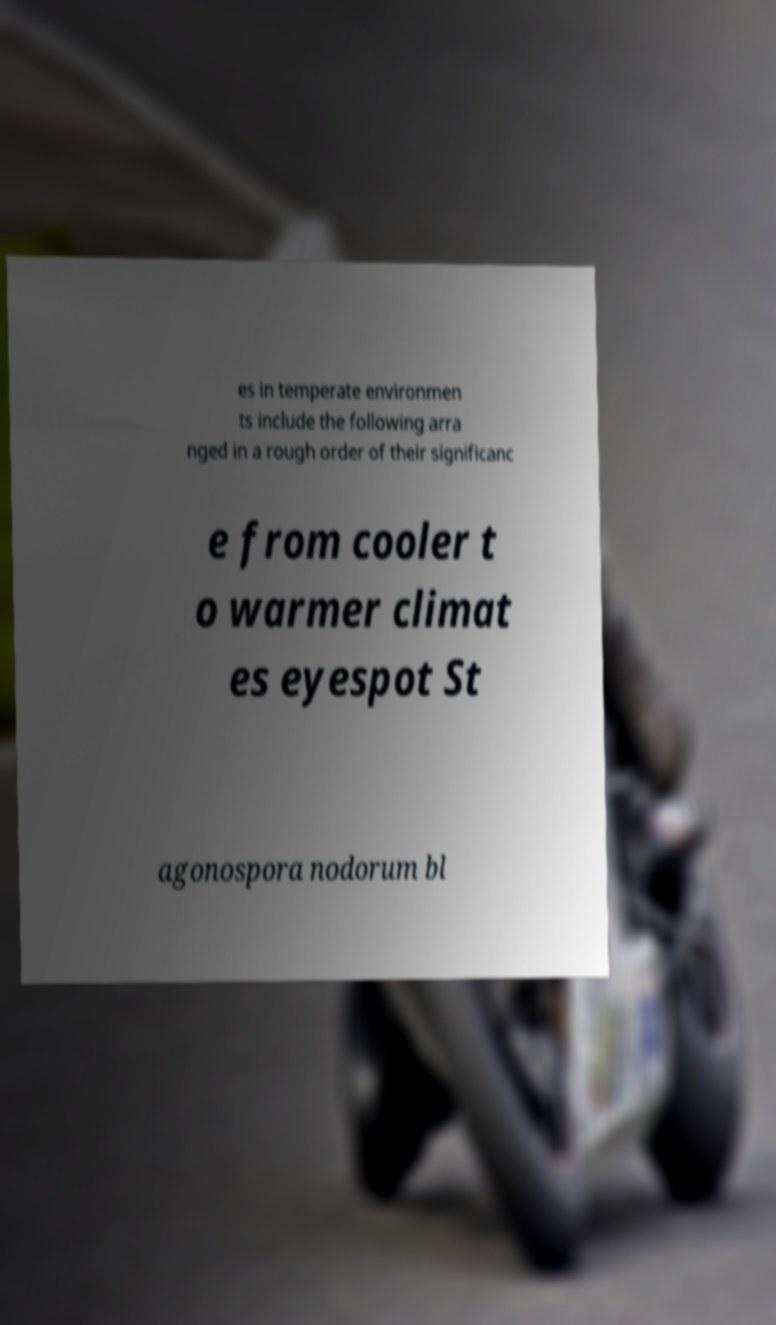There's text embedded in this image that I need extracted. Can you transcribe it verbatim? es in temperate environmen ts include the following arra nged in a rough order of their significanc e from cooler t o warmer climat es eyespot St agonospora nodorum bl 